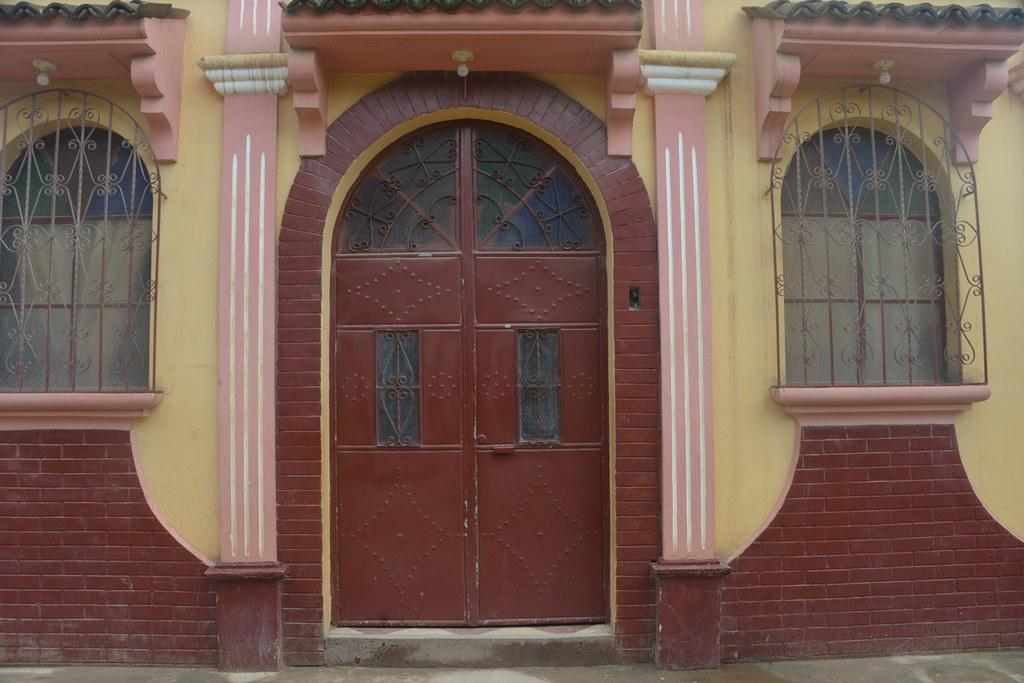What type of structure is visible in the image? There is a building in the image. What features can be seen on the building? The building has windows and doors. Are there any additional elements on the building? Yes, there are lights at the top of the building. What is visible at the bottom of the image? There is a road at the bottom of the image. Can you hear any songs being played near the lake in the image? There is no lake or songs present in the image; it features a building with lights, windows, and doors, as well as a road at the bottom. 